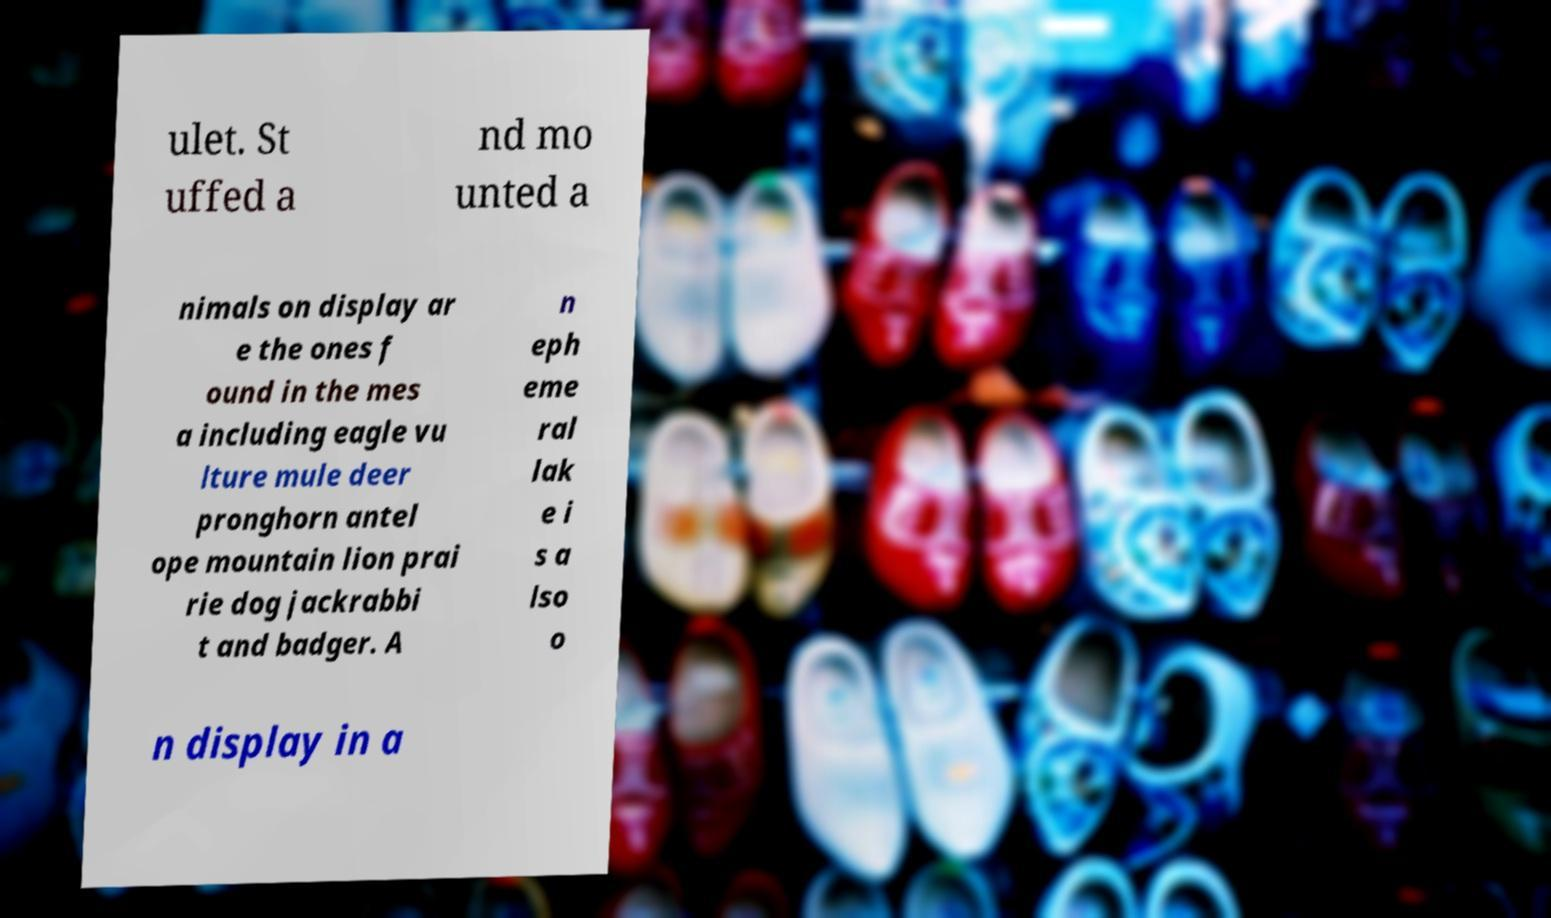Can you accurately transcribe the text from the provided image for me? ulet. St uffed a nd mo unted a nimals on display ar e the ones f ound in the mes a including eagle vu lture mule deer pronghorn antel ope mountain lion prai rie dog jackrabbi t and badger. A n eph eme ral lak e i s a lso o n display in a 